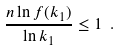<formula> <loc_0><loc_0><loc_500><loc_500>\frac { n \ln f ( k _ { 1 } ) } { \ln k _ { 1 } } \leq 1 \ .</formula> 